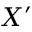<formula> <loc_0><loc_0><loc_500><loc_500>X ^ { \prime }</formula> 